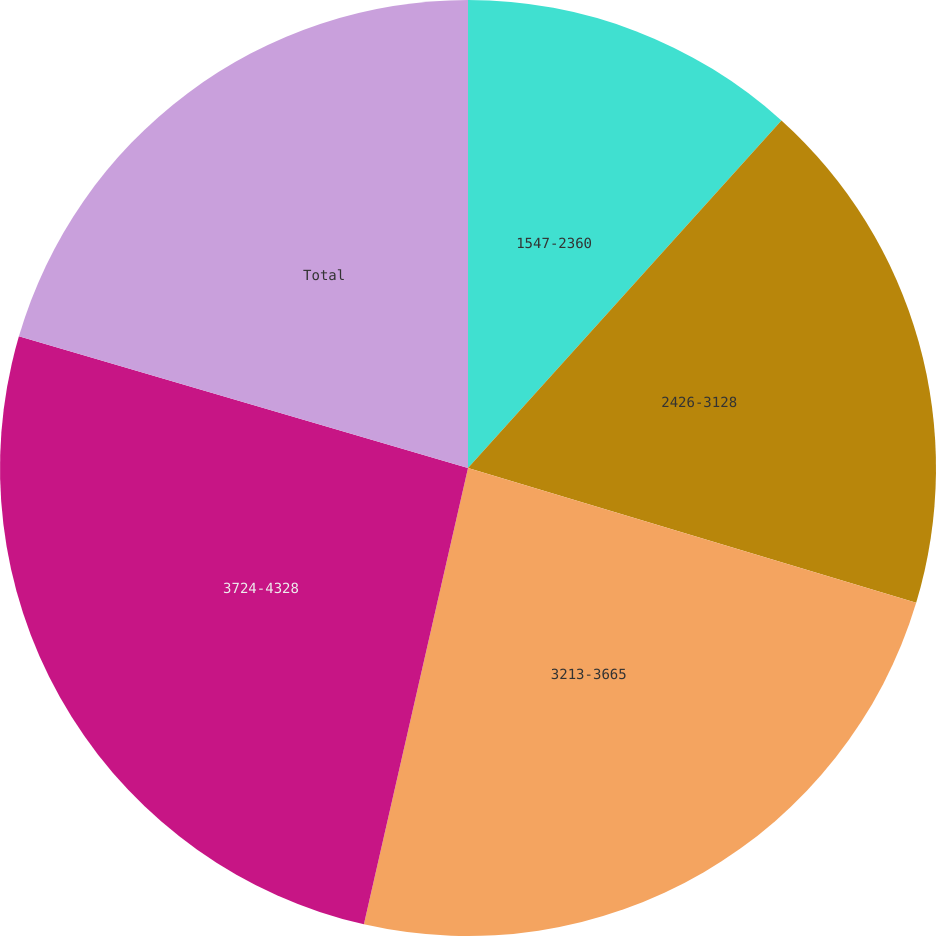<chart> <loc_0><loc_0><loc_500><loc_500><pie_chart><fcel>1547-2360<fcel>2426-3128<fcel>3213-3665<fcel>3724-4328<fcel>Total<nl><fcel>11.68%<fcel>17.97%<fcel>23.92%<fcel>25.97%<fcel>20.46%<nl></chart> 